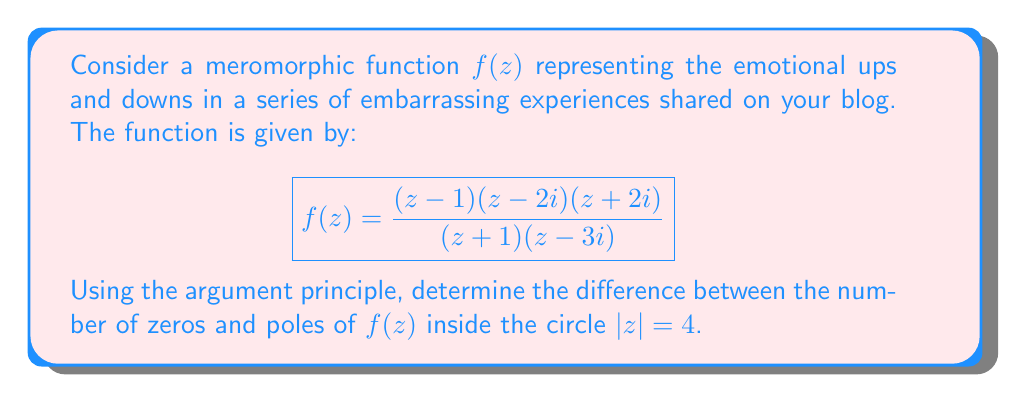Teach me how to tackle this problem. Let's approach this step-by-step:

1) The argument principle states that for a meromorphic function $f(z)$, the integral
   
   $$\frac{1}{2\pi i} \oint_C \frac{f'(z)}{f(z)} dz = N - P$$
   
   where $N$ is the number of zeros and $P$ is the number of poles of $f(z)$ inside the contour $C$, counting multiplicity.

2) In our case, $C$ is the circle $|z| = 4$.

3) Let's identify the zeros and poles of $f(z)$:
   Zeros: $z = 1$, $z = 2i$, $z = -2i$
   Poles: $z = -1$, $z = 3i$

4) All these points lie inside the circle $|z| = 4$.

5) Instead of computing the integral directly, we can use the fact that the integral counts the difference between zeros and poles inside $C$.

6) Count of zeros inside $C$: 3
   Count of poles inside $C$: 2

7) Therefore, the difference $N - P = 3 - 2 = 1$

This result can be interpreted as the net "positivity" of your embarrassing experiences, with zeros representing highs and poles representing lows in your storytelling journey.
Answer: The difference between the number of zeros and poles of $f(z)$ inside $|z| = 4$ is 1. 